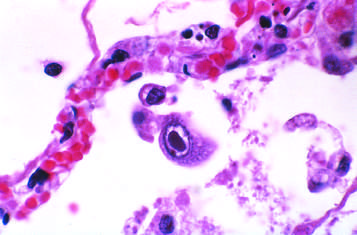do energy stores show distinct nuclear inclusions?
Answer the question using a single word or phrase. No 